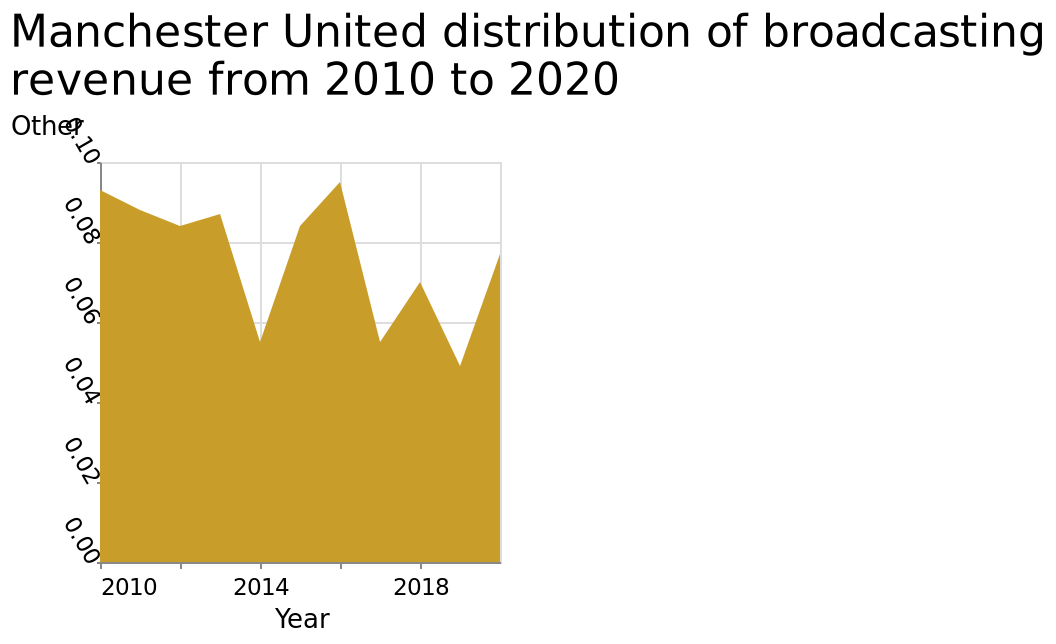<image>
What does the y-axis represent in the Manchester United broadcasting revenue distribution plot?  The y-axis represents the "Other" category in a linear scale ranging from 0.00 to 0.10. Offer a thorough analysis of the image. Over the ten years, the distrubition of  broadcasting revenue has been very up and down. What is the range of the x-axis in the Manchester United broadcasting revenue distribution plot?  The x-axis range in the plot is from 2010 to 2018. What was the year with the highest distribution of broadcasting?  2016 please summary the statistics and relations of the chart 2016 was the highest year of distribution of broadcasting from 2010 until 2020. From 2010 until 2020 the distribution of broadcasting has decreased. Has the distribution of broadcasting been consistently increasing from 2010 to 2020? No, it has been decreasing. 